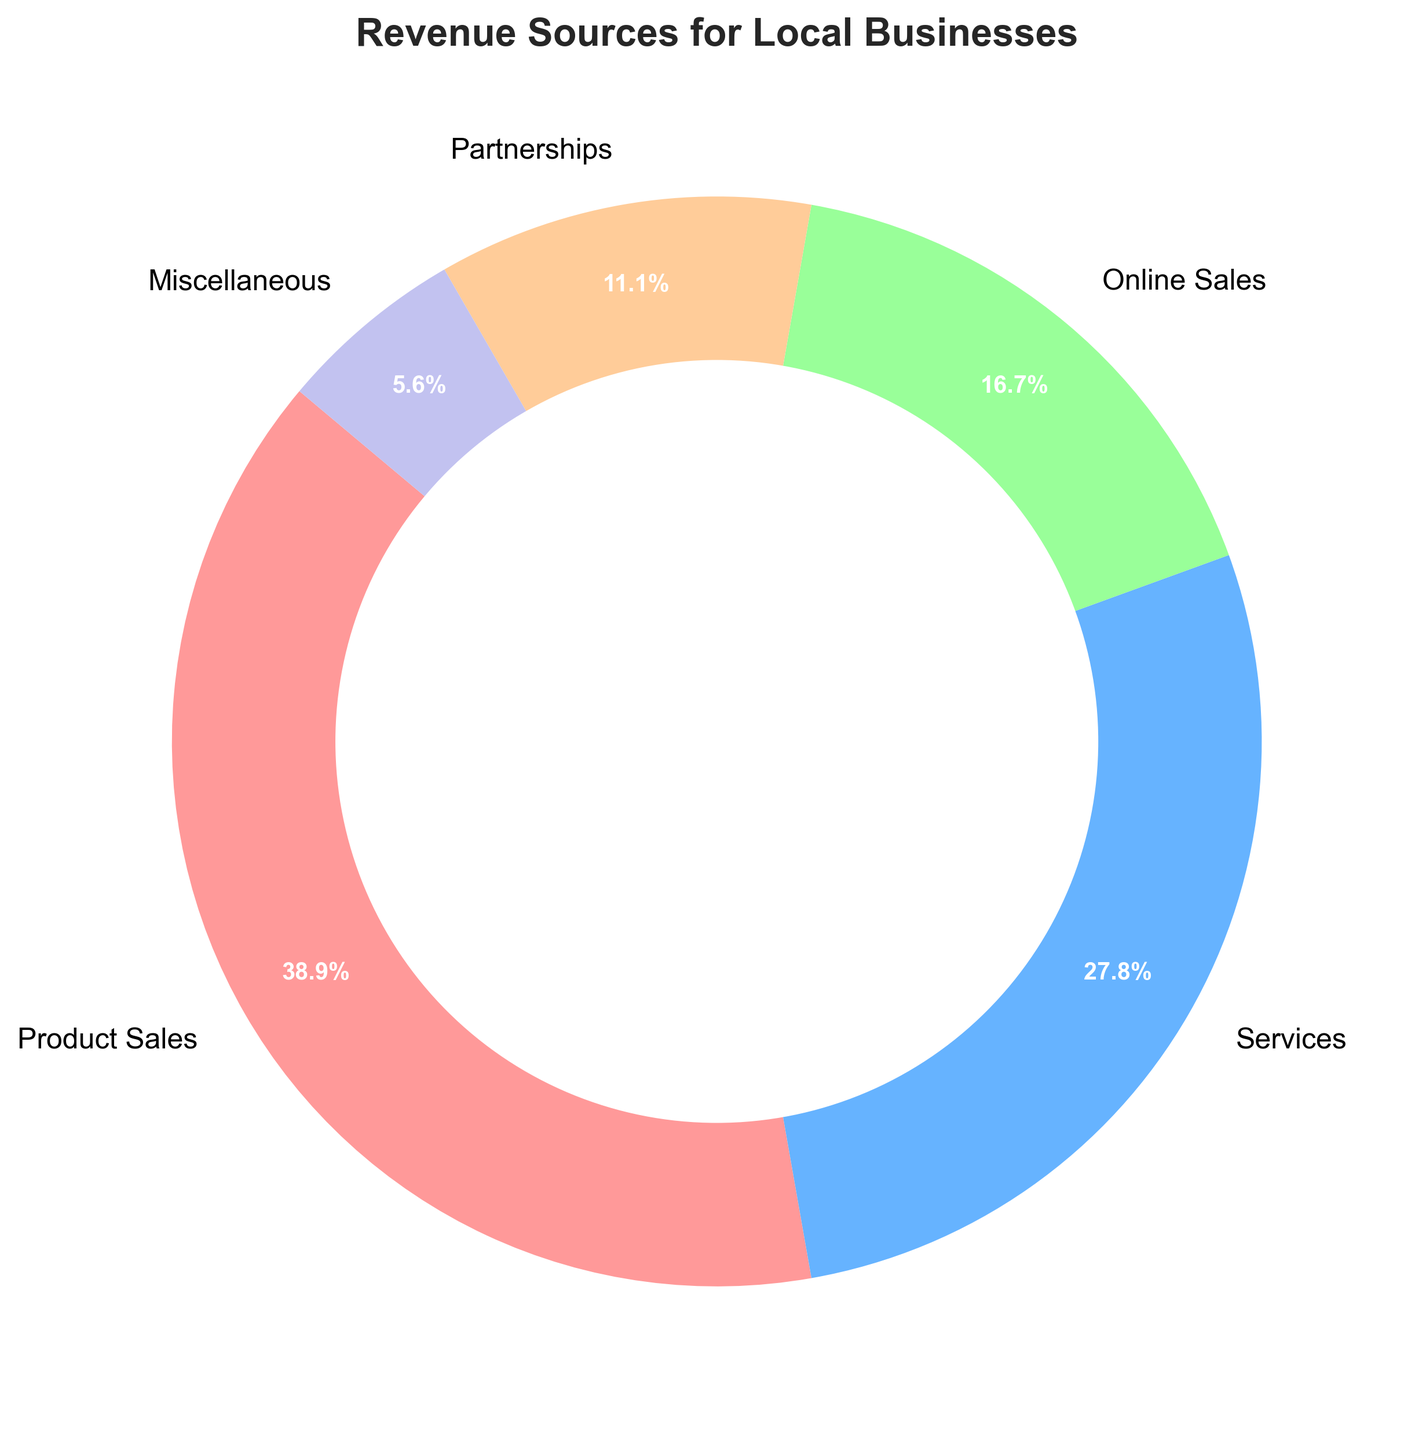What's the largest source of revenue for local businesses according to the figure? The figure shows different categories of revenue, each labeled with a percentage. The category with the highest percentage is the largest source of revenue.
Answer: Product Sales What's the smallest source of revenue for local businesses? By looking at the wedge with the smallest percentage labeled in the pie chart, we can see which category has the least revenue.
Answer: Miscellaneous How much more revenue does Product Sales generate compared to Online Sales? Find the percentages for Product Sales and Online Sales from the chart, convert these percentages to their respective absolute values if necessary (35,000 for Product Sales and 15,000 for Online Sales), and then subtract the smaller value from the larger one. 35,000 - 15,000 = 20,000
Answer: 20,000 What percentage of total revenue do Partnerships and Miscellaneous combined make up? First, find the percentage for Partnerships and Miscellaneous, which are labeled in the pie chart (10,000 and 5,000 in absolute values). Sum these amounts (10,000 + 5,000 = 15,000), divide by the total revenue (35,000 + 25,000 + 15,000 + 10,000 + 5,000 = 90,000), and multiply by 100 to find the percentage. (15,000/90,000) * 100 ≈ 16.7%
Answer: 16.7% If the Services revenue increased by 5,000, what would be the new percentage of the revenue for Services? Add 5,000 to the current Services revenue (25,000 + 5,000 = 30,000). The new total revenue becomes 95,000. Calculate the new percentage by (30,000 / 95,000) * 100 ≈ 31.6%
Answer: 31.6% Which revenue source has the second highest share? Reviewing the percentages labeled in the pie chart, identify the category with the second highest percentage.
Answer: Services How do the combined revenues from Online Sales and Partnerships compare to Product Sales? Find the absolute values for Online Sales (15,000) and Partnerships (10,000), then sum these amounts (15,000 + 10,000 = 25,000). Compare this sum to the Product Sales amount (35,000). 25,000 is less than 35,000.
Answer: Less Which part of the pie chart is represented by a green color? The pie chart uses distinct colors to represent different categories. Identify the category associated with the green wedge in the figure.
Answer: Online Sales Is the revenue from Miscellaneous closer to the revenue of Services or Online Sales? Compare the absolute value of Miscellaneous (5,000) to the absolute values of Services (25,000) and Online Sales (15,000). 5,000 is closer to 15,000 than to 25,000.
Answer: Online Sales 